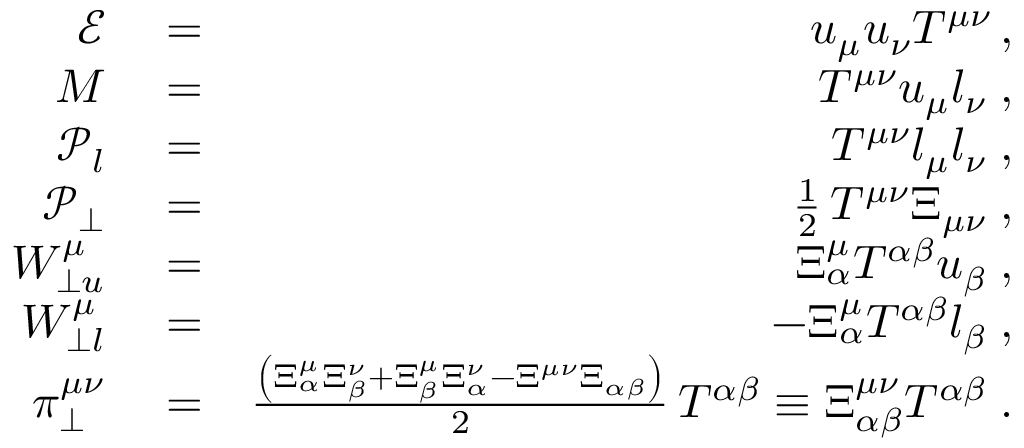<formula> <loc_0><loc_0><loc_500><loc_500>\begin{array} { r l r } { \mathcal { E } } & = } & { u _ { \mu } u _ { \nu } T ^ { \mu \nu } \, , } \\ { M } & = } & { T ^ { \mu \nu } u _ { \mu } l _ { \nu } \, , } \\ { \mathcal { P } _ { l } } & = } & { T ^ { \mu \nu } l _ { \mu } l _ { \nu } \, , } \\ { \mathcal { P } _ { \perp } } & = } & { \frac { 1 } { 2 } \, T ^ { \mu \nu } \Xi _ { \mu \nu } \, , } \\ { W _ { \perp u } ^ { \mu } } & = } & { \Xi _ { \alpha } ^ { \mu } T ^ { \alpha \beta } u _ { \beta } \, , } \\ { W _ { \perp l } ^ { \mu } } & = } & { - \Xi _ { \alpha } ^ { \mu } T ^ { \alpha \beta } l _ { \beta } \, , } \\ { \pi _ { \perp } ^ { \mu \nu } } & = } & { \frac { \left ( \Xi _ { \alpha } ^ { \mu } \Xi _ { \beta } ^ { \nu } + \Xi _ { \beta } ^ { \mu } \Xi _ { \alpha } ^ { \nu } - \Xi ^ { \mu \nu } \Xi _ { \alpha \beta } \right ) } { 2 } \, T ^ { \alpha \beta } \equiv \Xi _ { \alpha \beta } ^ { \mu \nu } T ^ { \alpha \beta } \, . } \end{array}</formula> 